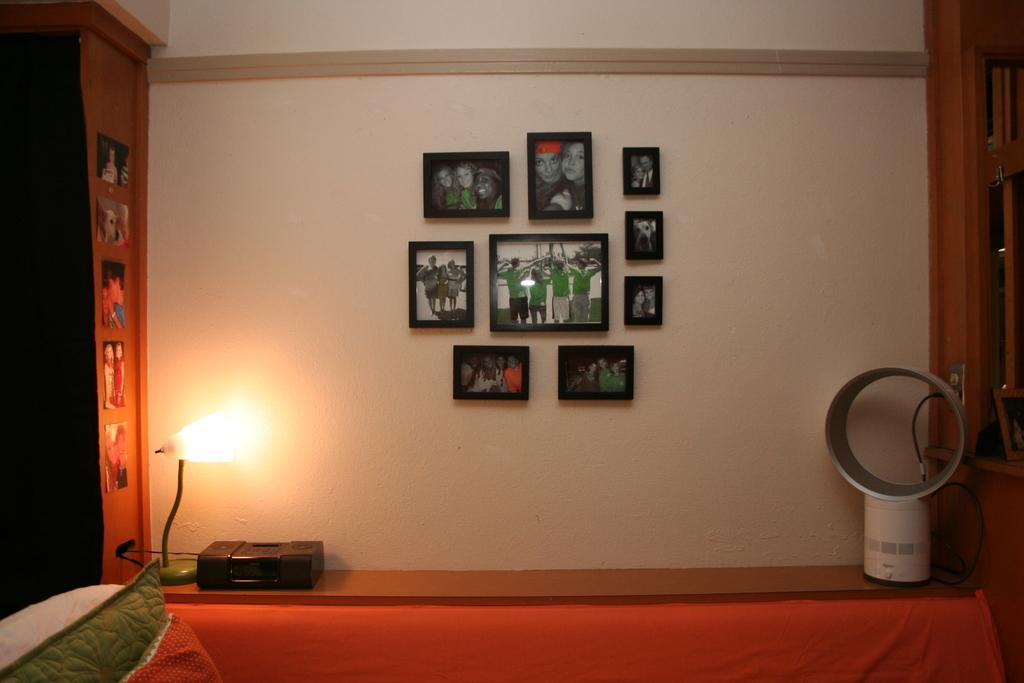What type of soft furnishings can be seen in the image? There are pillows in the image. What electronic device is present in the image? There is a device in the image. What type of lighting is present in the image? There is a lamp in the image. What type of personal items are present in the image? There are photos in the image. What type of cable is present in the image? There is a cable in the image. What type of decorative items are present on the wall in the image? There are photo frames on the wall in the image. Can you describe the unspecified objects in the image? Unfortunately, the facts provided do not specify the nature of the unspecified objects in the image. What type of punishment is being administered to the laborer in the image? There is no laborer or punishment present in the image. What type of measuring device is being used in the image? There is no measuring device present in the image. 